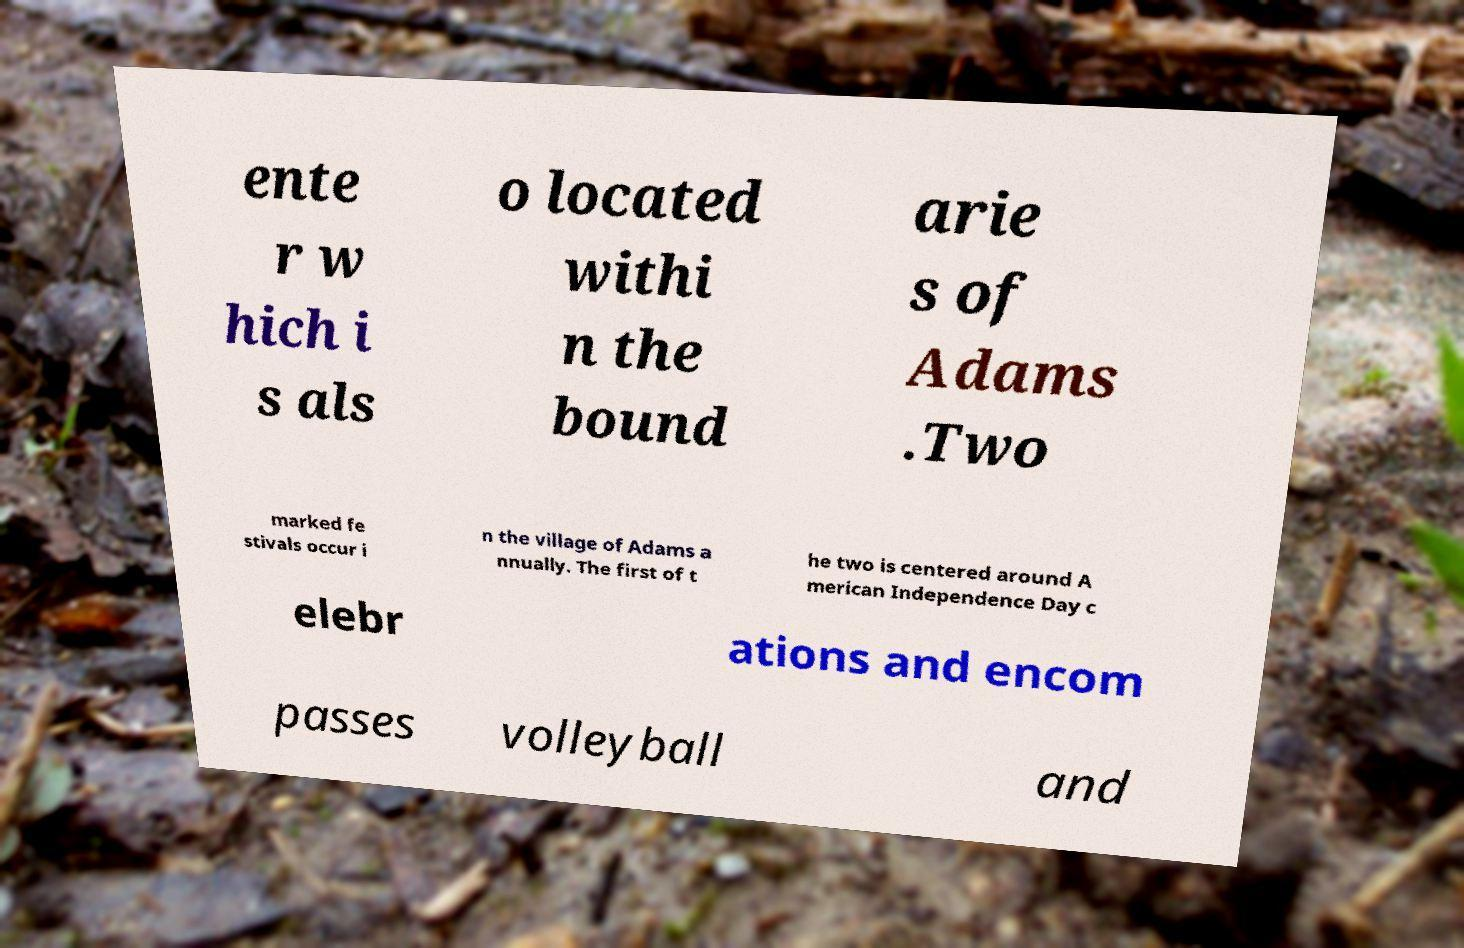Could you assist in decoding the text presented in this image and type it out clearly? ente r w hich i s als o located withi n the bound arie s of Adams .Two marked fe stivals occur i n the village of Adams a nnually. The first of t he two is centered around A merican Independence Day c elebr ations and encom passes volleyball and 